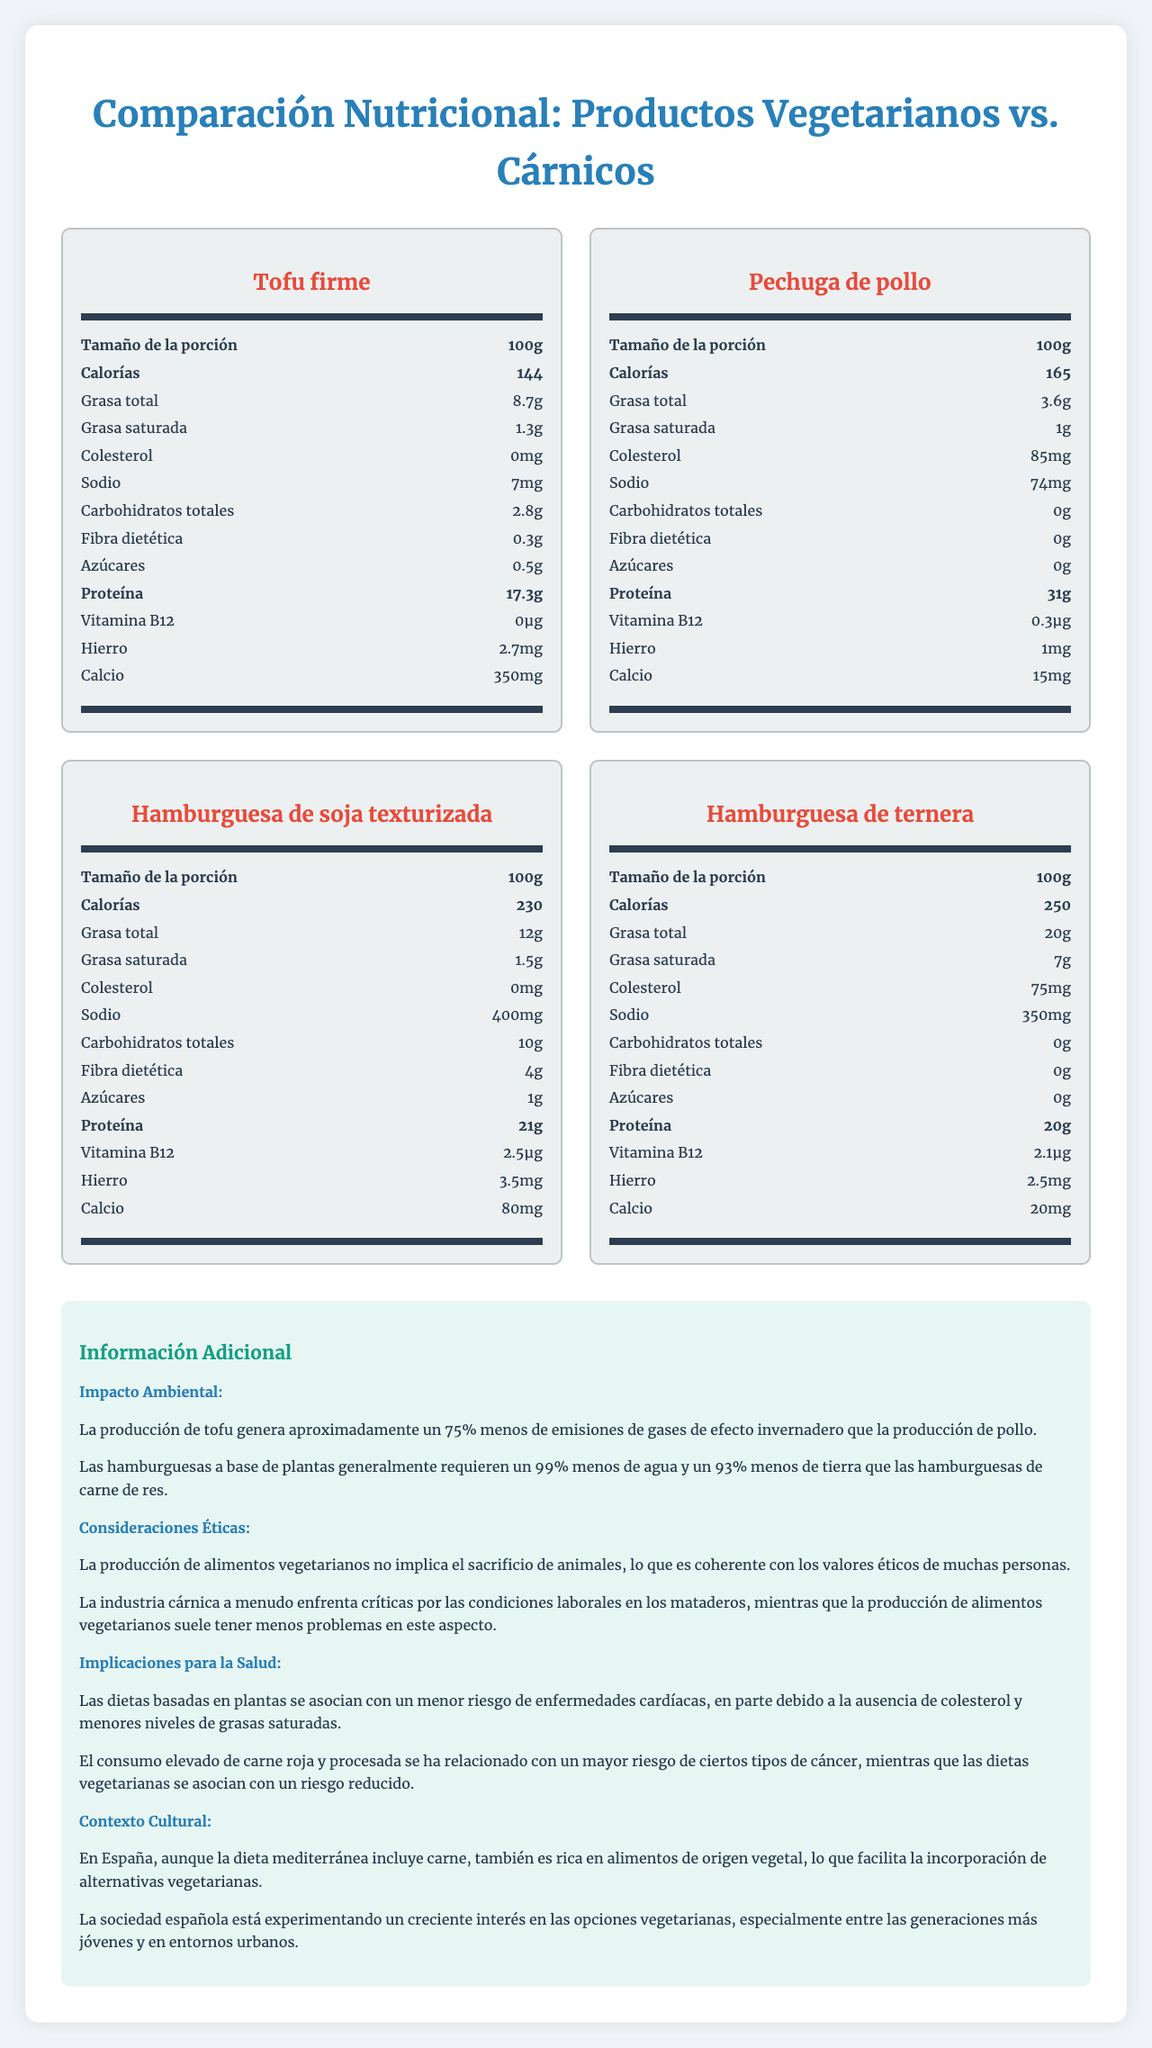What is the serving size of Pechuga de pollo? The document specifies a serving size of 100g for Pechuga de pollo.
Answer: 100g Which product contains the highest amount of protein per serving? A. Tofu firme B. Hamburguesa de soja texturizada C. Pechuga de pollo D. Hamburguesa de ternera Pechuga de pollo has 31g of protein per 100g serving, which is the highest among the listed products.
Answer: C. Pechuga de pollo Is there any cholesterol in Tofu firme? Tofu firme has 0mg of cholesterol per serving.
Answer: No Which vegetarian product has a higher iron content? A. Tofu firme B. Hamburguesa de soja texturizada Hamburguesa de soja texturizada contains 3.5mg of iron, while Tofu firme contains 2.7mg.
Answer: B. Hamburguesa de soja texturizada How does the sodium content of Hamburguesa de ternera compare to Hamburguesa de soja texturizada? Hamburguesa de ternera has 350mg sodium per 100g, whereas Hamburguesa de soja texturizada has 400mg.
Answer: It is lower in Hamburguesa de ternera Does the document provide information on how much water is required to produce plant-based burgers compared to beef burgers? The document states that plant-based burgers generally require 99% less water than beef burgers.
Answer: Yes What is the main vitamin present in Hamburguesa de ternera’s nutrition label, and how much of it is there? Hamburguesa de ternera has 2.1µg of Vitamin B12.
Answer: Vitamin B12, 2.1µg Summarize the main environmental impact discussed regarding plant-based versus meat products. The document indicates that tofu production generates about 75% less greenhouse gas emissions compared to chicken, and plant-based burgers require 99% less water and 93% less land than beef burgers.
Answer: Plant-based products generally have lower environmental impacts Which product has the highest total fat content? A. Tofu firme B. Hamburguesa de soja texturizada C. Pechuga de pollo D. Hamburguesa de ternera Hamburguesa de ternera has 20g of total fat per 100g serving, which is the highest among the listed products.
Answer: D. Hamburguesa de ternera Is the amount of calcium higher in Tofu firme or Pechuga de pollo? Tofu firme has 350mg of calcium per serving, whereas Pechuga de pollo only has 15mg.
Answer: Tofu firme Does Pechuga de pollo contain any fiber? Pechuga de pollo has 0g of dietary fiber per serving.
Answer: No What is the difference in calorie content between Tofu firme and Hamburguesa de soja texturizada? Hamburguesa de soja texturizada has 230 calories per 100g, while Tofu firme has 144 calories, making an 86 calorie difference.
Answer: 86 calories How does the document address the ethical considerations surrounding vegetarian and meat products? The document explains that vegetarian food production doesn’t involve animal slaughter and usually has better worker conditions compared to the meat industry, which often faces criticism for labor conditions in slaughterhouses.
Answer: It discusses animal welfare and worker conditions Which product is a source of dietary fiber? A. Tofu firme B. Hamburguesa de soja texturizada C. Pechuga de pollo D. Hamburguesa de ternera Hamburguesa de soja texturizada has 4g of dietary fiber per serving, while the other products have none.
Answer: B. Hamburguesa de soja texturizada Does the document provide specific recipes for using the vegetarian or meat products? The document focuses on nutritional facts and comparisons but does not provide recipes.
Answer: No, it does not 